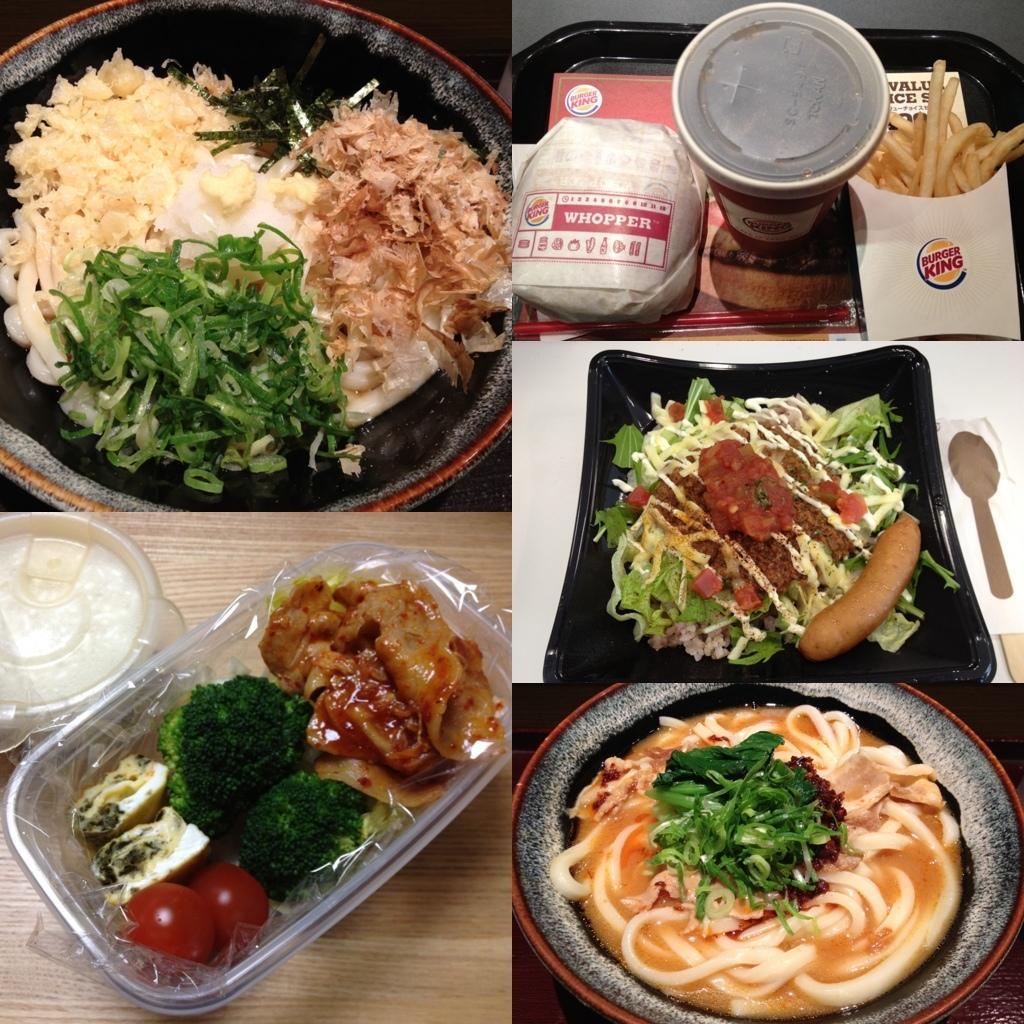Could you give a brief overview of what you see in this image? In this image I can see few food items, they are in green, brown, white and red color. The food items are in the plats and bowls and the plats are in black color. 